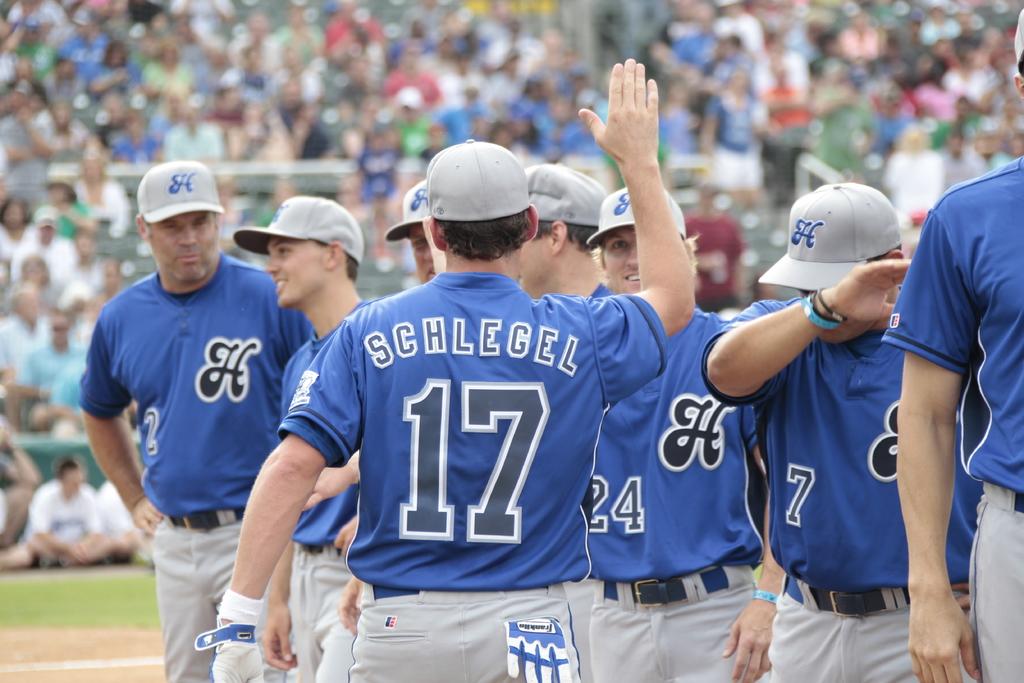What is the last name of the player who wears the number 17 on his jersey?
Offer a very short reply. Schlegel. What team is this?
Provide a succinct answer. H. 